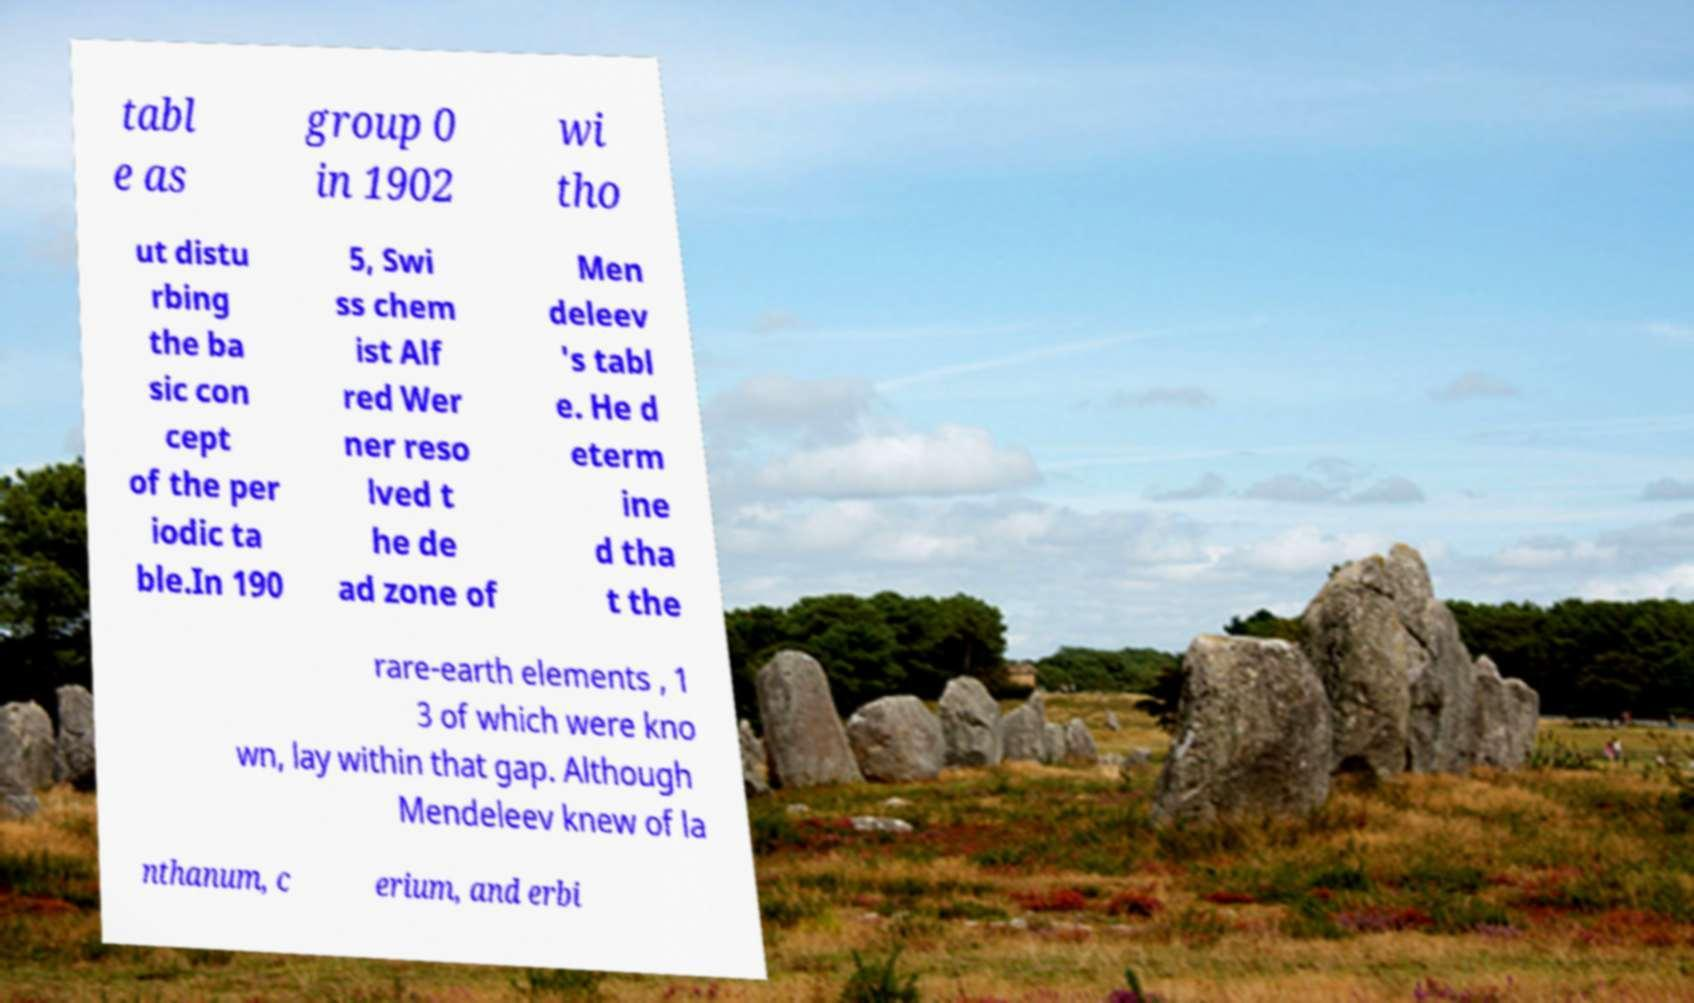There's text embedded in this image that I need extracted. Can you transcribe it verbatim? tabl e as group 0 in 1902 wi tho ut distu rbing the ba sic con cept of the per iodic ta ble.In 190 5, Swi ss chem ist Alf red Wer ner reso lved t he de ad zone of Men deleev 's tabl e. He d eterm ine d tha t the rare-earth elements , 1 3 of which were kno wn, lay within that gap. Although Mendeleev knew of la nthanum, c erium, and erbi 